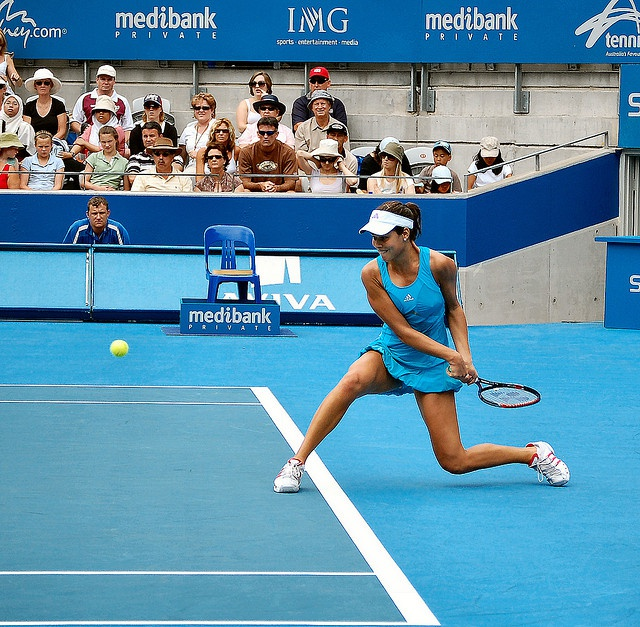Describe the objects in this image and their specific colors. I can see people in darkblue, white, black, darkgray, and maroon tones, people in darkblue, brown, lightblue, black, and white tones, chair in darkblue, blue, lightblue, and black tones, people in darkblue, maroon, black, and brown tones, and people in darkblue, white, black, maroon, and darkgray tones in this image. 